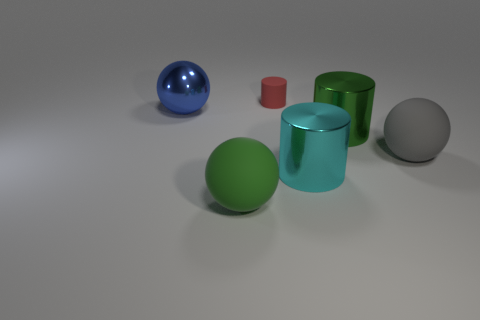Add 1 big metallic cylinders. How many objects exist? 7 Subtract all green shiny cylinders. How many cylinders are left? 2 Subtract all gray balls. How many balls are left? 2 Subtract 1 green spheres. How many objects are left? 5 Subtract 2 spheres. How many spheres are left? 1 Subtract all yellow cylinders. Subtract all green balls. How many cylinders are left? 3 Subtract all blue blocks. How many brown spheres are left? 0 Subtract all purple cylinders. Subtract all tiny red rubber cylinders. How many objects are left? 5 Add 1 big green spheres. How many big green spheres are left? 2 Add 6 gray objects. How many gray objects exist? 7 